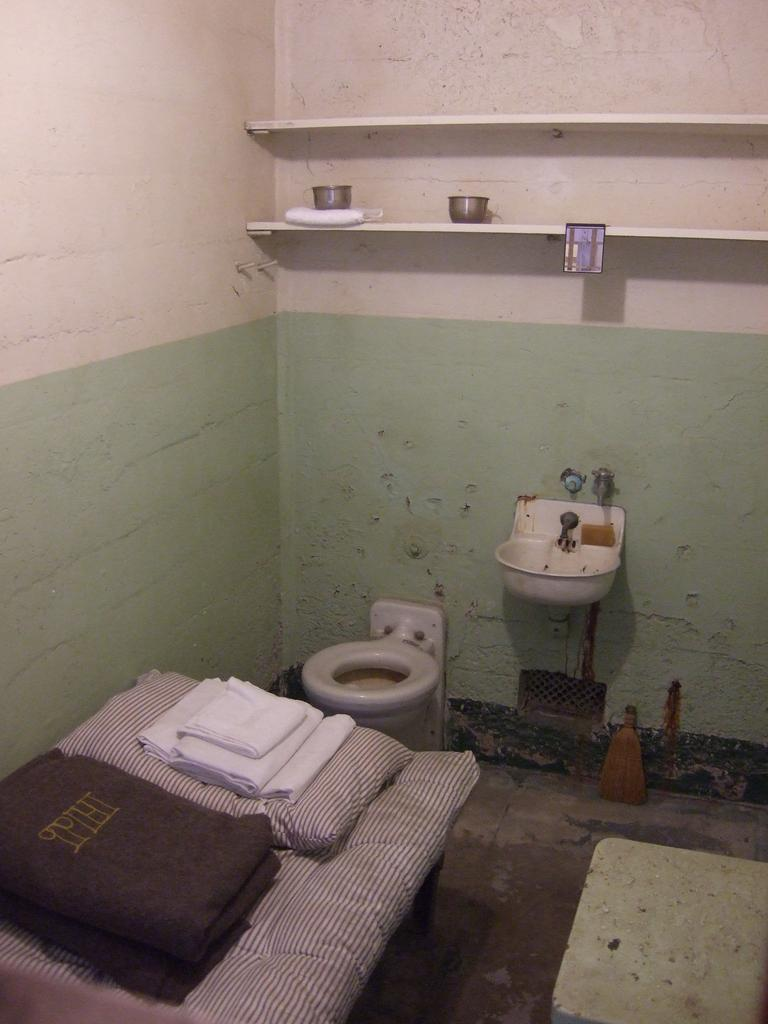What piece of furniture is present in the image? There is a table in the image. What is placed on the table? There is a towel and a pillow on the table. What can be seen in the background of the image? There is a toilet seat, a sink, and a wall in the background of the image. What type of beast is lurking in the background of the image? There is no beast present in the image; the background features a toilet seat, a sink, and a wall. 